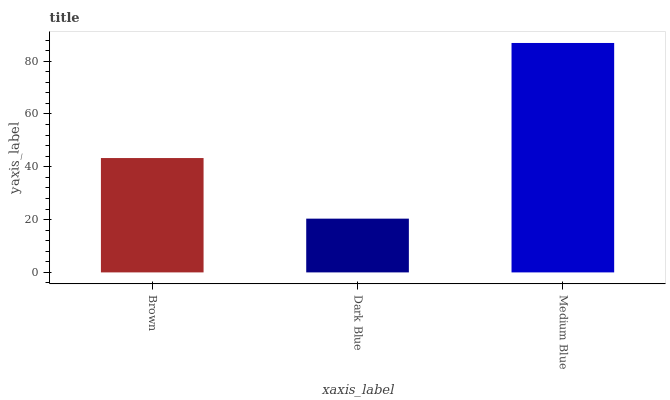Is Dark Blue the minimum?
Answer yes or no. Yes. Is Medium Blue the maximum?
Answer yes or no. Yes. Is Medium Blue the minimum?
Answer yes or no. No. Is Dark Blue the maximum?
Answer yes or no. No. Is Medium Blue greater than Dark Blue?
Answer yes or no. Yes. Is Dark Blue less than Medium Blue?
Answer yes or no. Yes. Is Dark Blue greater than Medium Blue?
Answer yes or no. No. Is Medium Blue less than Dark Blue?
Answer yes or no. No. Is Brown the high median?
Answer yes or no. Yes. Is Brown the low median?
Answer yes or no. Yes. Is Medium Blue the high median?
Answer yes or no. No. Is Dark Blue the low median?
Answer yes or no. No. 